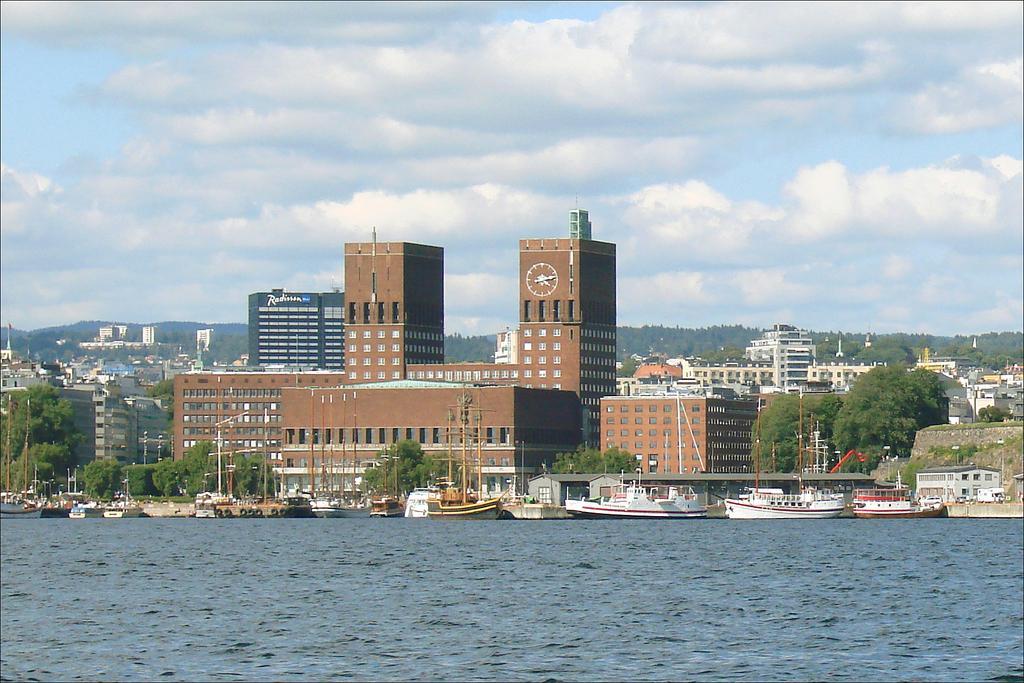Can you describe this image briefly? In the background of the image there are buildings,trees,poles. At the top of the image there is sky and clouds. At the bottom of the image there is water. There are boats. 